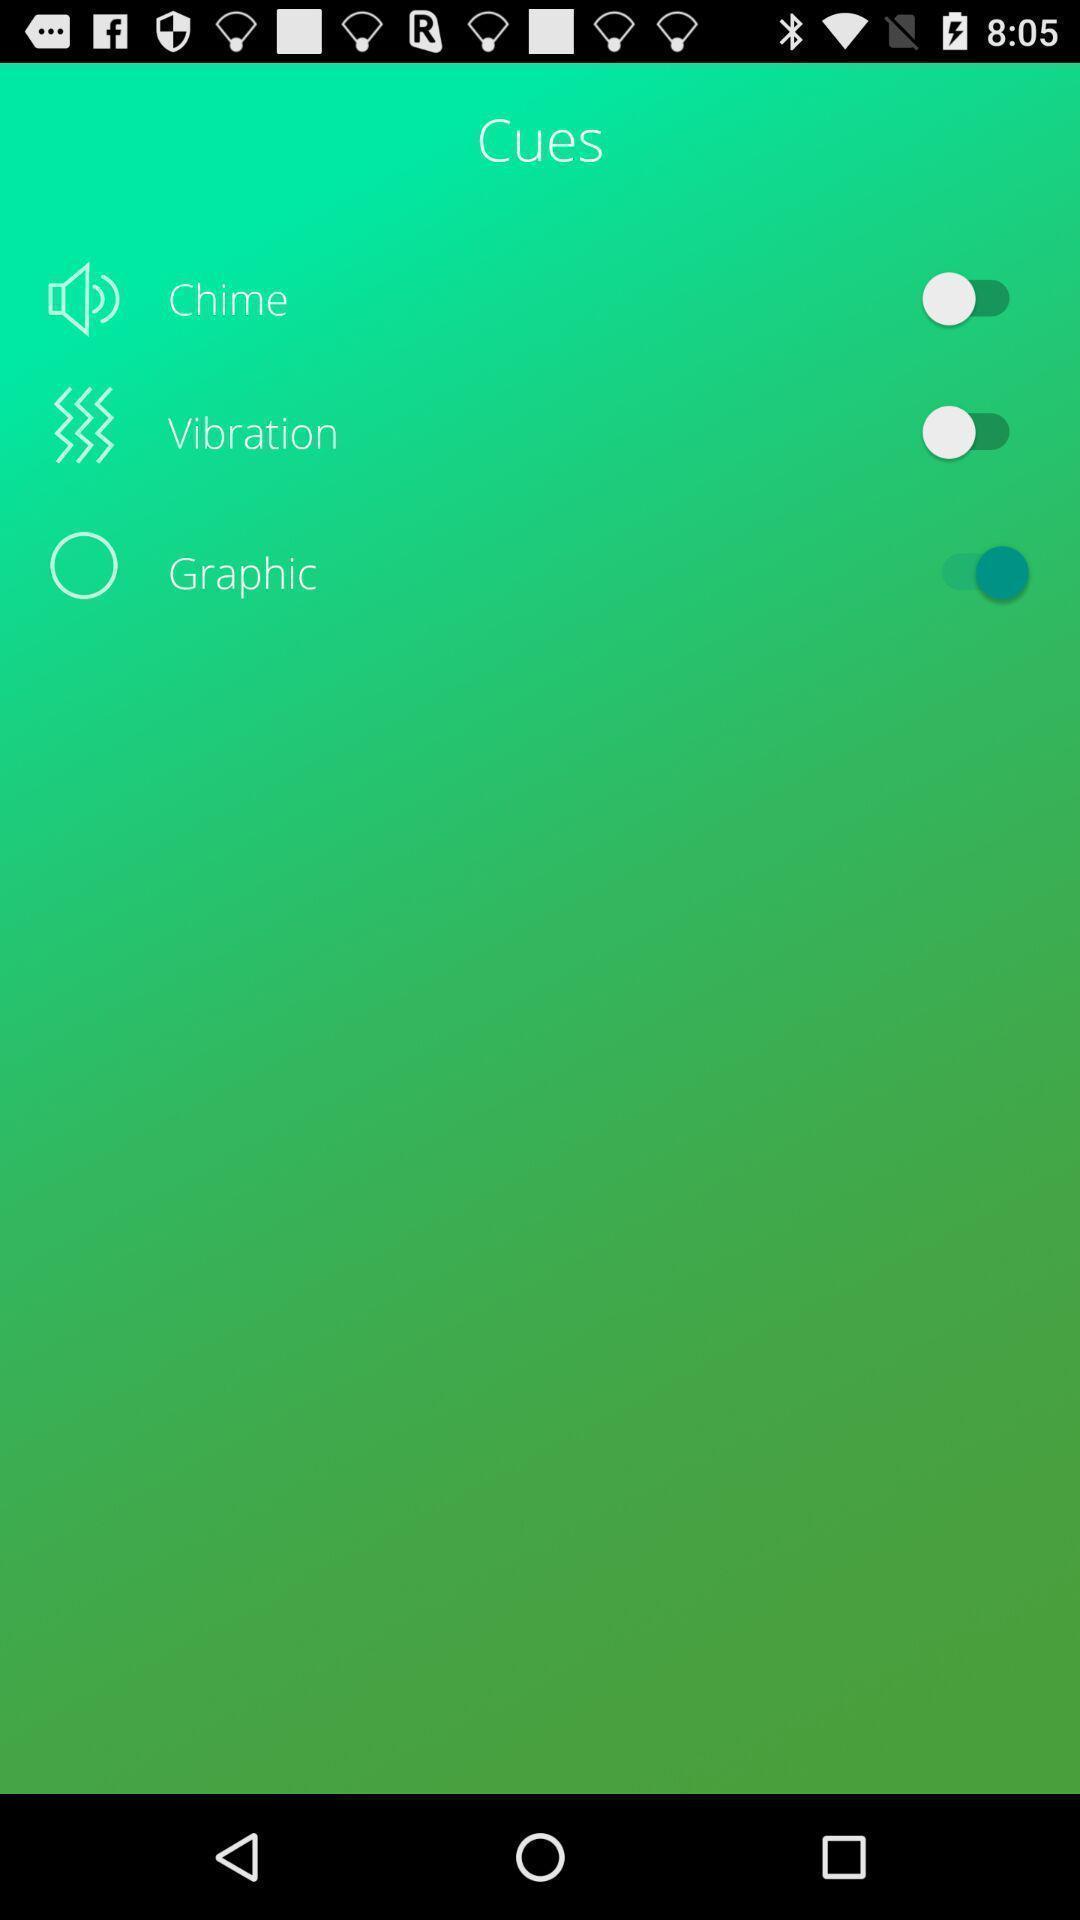Tell me what you see in this picture. Page displays settings in app. 